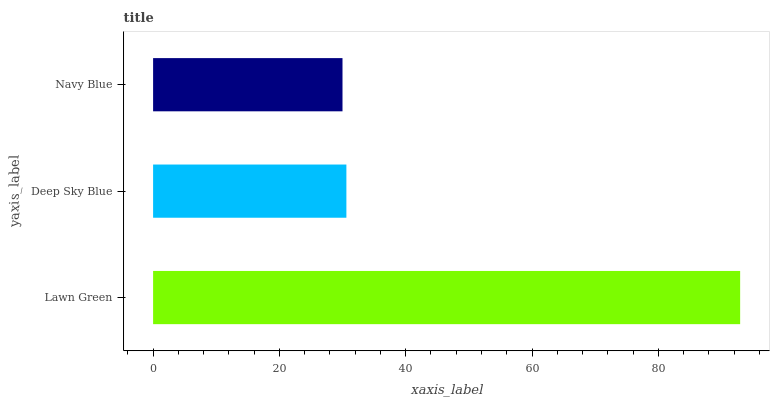Is Navy Blue the minimum?
Answer yes or no. Yes. Is Lawn Green the maximum?
Answer yes or no. Yes. Is Deep Sky Blue the minimum?
Answer yes or no. No. Is Deep Sky Blue the maximum?
Answer yes or no. No. Is Lawn Green greater than Deep Sky Blue?
Answer yes or no. Yes. Is Deep Sky Blue less than Lawn Green?
Answer yes or no. Yes. Is Deep Sky Blue greater than Lawn Green?
Answer yes or no. No. Is Lawn Green less than Deep Sky Blue?
Answer yes or no. No. Is Deep Sky Blue the high median?
Answer yes or no. Yes. Is Deep Sky Blue the low median?
Answer yes or no. Yes. Is Lawn Green the high median?
Answer yes or no. No. Is Lawn Green the low median?
Answer yes or no. No. 